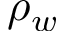Convert formula to latex. <formula><loc_0><loc_0><loc_500><loc_500>\rho _ { w }</formula> 